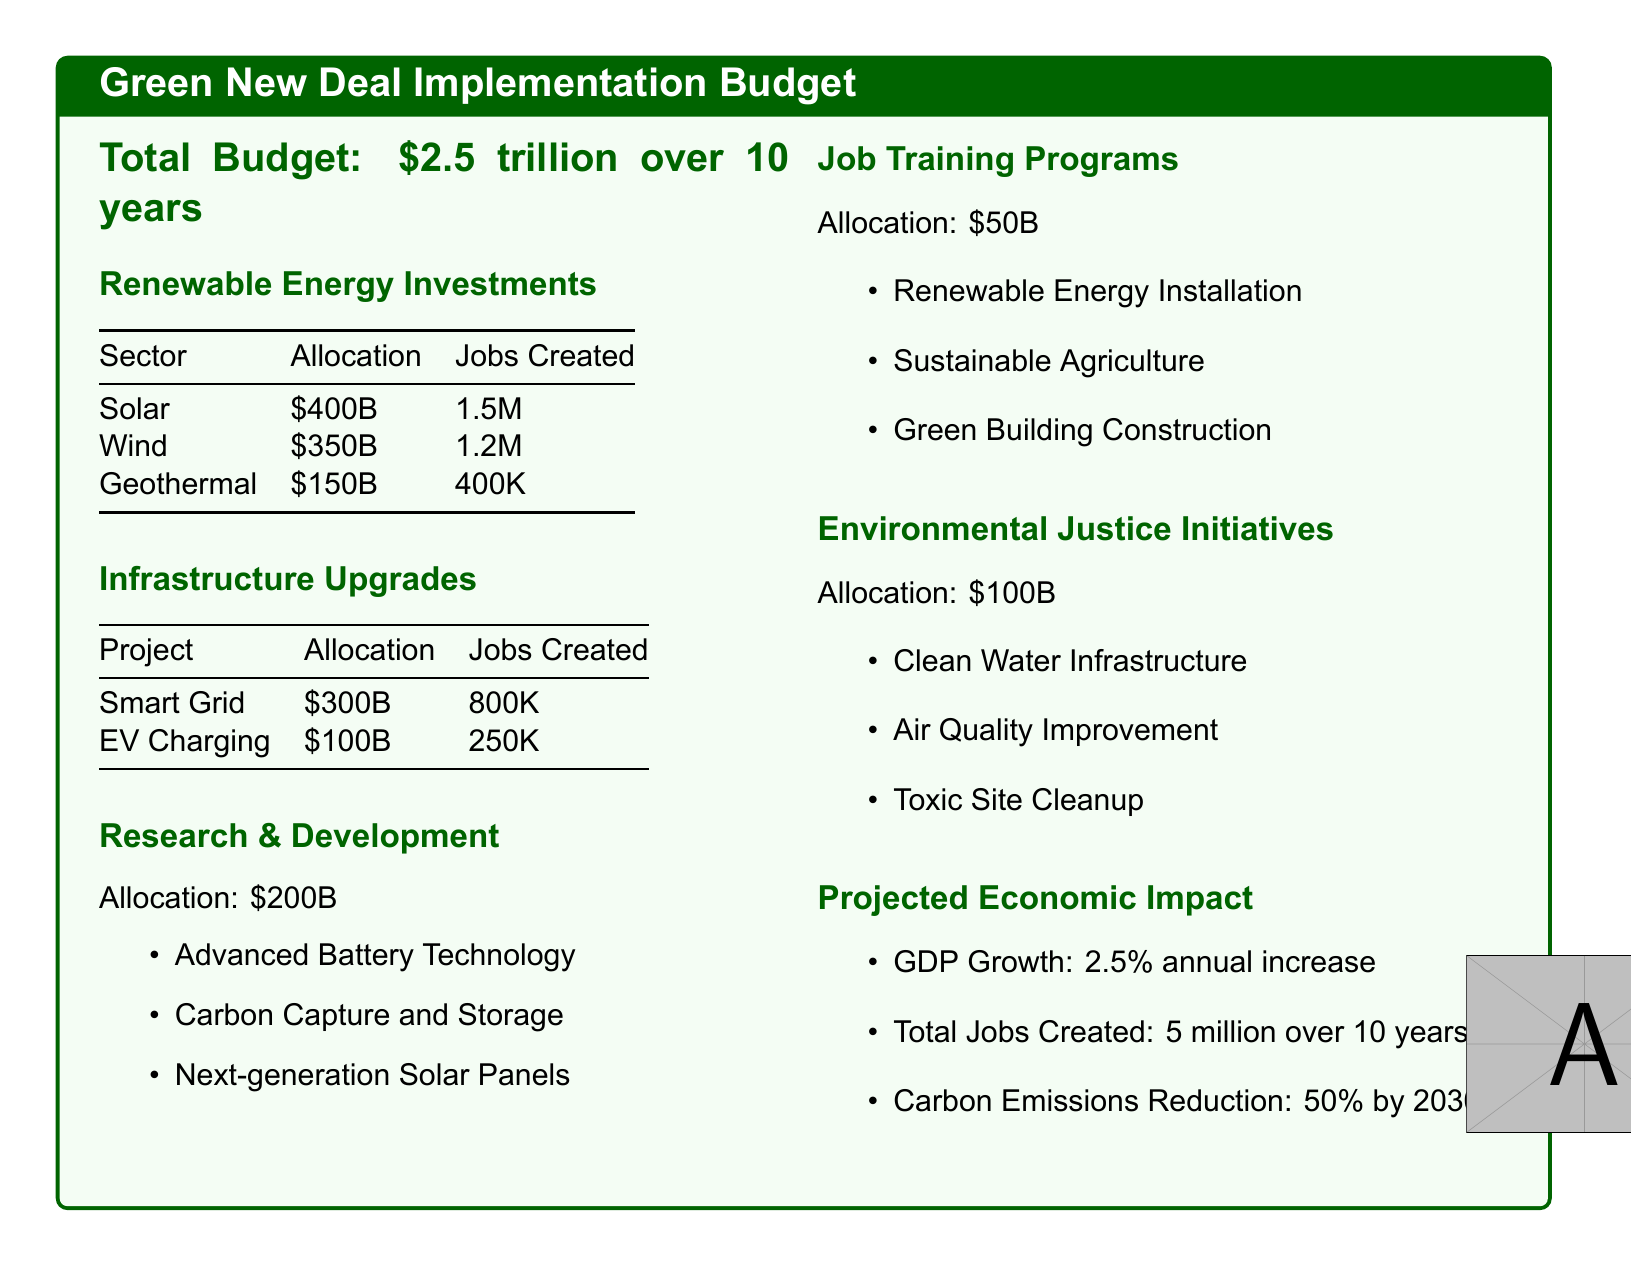what is the total budget? The total budget is stated at the beginning of the document.
Answer: \$2.5 trillion over 10 years how much is allocated to solar energy? The allocation for solar energy is listed in the renewable energy investments section.
Answer: \$400B how many jobs are created by wind energy investments? The number of jobs created by wind energy is found in the jobs created column of the renewable energy investments table.
Answer: 1.2M what is the total number of jobs projected to be created? The total number of jobs is found in the projected economic impact section.
Answer: 5 million over 10 years what is the allocation for research and development? The allocation for research and development is specified in that section of the document.
Answer: \$200B which initiative has the highest allocation under environmental justice? You can find the allocations for environmental justice initiatives listed in that section, and clean water infrastructure is the most significant one.
Answer: Clean Water Infrastructure what is the expected annual GDP growth from the implementation? The expected GDP growth rate is stated in the projected economic impact section.
Answer: 2.5% annual increase how much funding is dedicated to job training programs? The funding for job training programs is outlined in that specific section.
Answer: \$50B what is the carbon emissions reduction target by 2030? The target for carbon emissions reduction is mentioned in the projected economic impact section.
Answer: 50% by 2030 